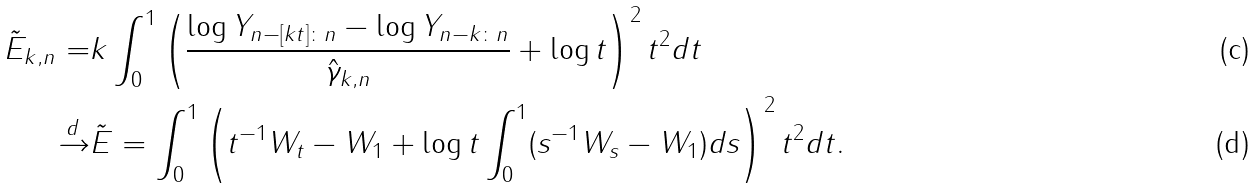<formula> <loc_0><loc_0><loc_500><loc_500>\tilde { E } _ { k , n } = & k \int _ { 0 } ^ { 1 } \left ( \frac { \log Y _ { n - [ k t ] \colon n } - \log Y _ { n - k \colon n } } { \hat { \gamma } _ { k , n } } + \log t \right ) ^ { 2 } t ^ { 2 } d t \\ \xrightarrow { d } & \tilde { E } = \int _ { 0 } ^ { 1 } \left ( t ^ { - 1 } W _ { t } - W _ { 1 } + \log t \int _ { 0 } ^ { 1 } ( s ^ { - 1 } W _ { s } - W _ { 1 } ) d s \right ) ^ { 2 } t ^ { 2 } d t .</formula> 